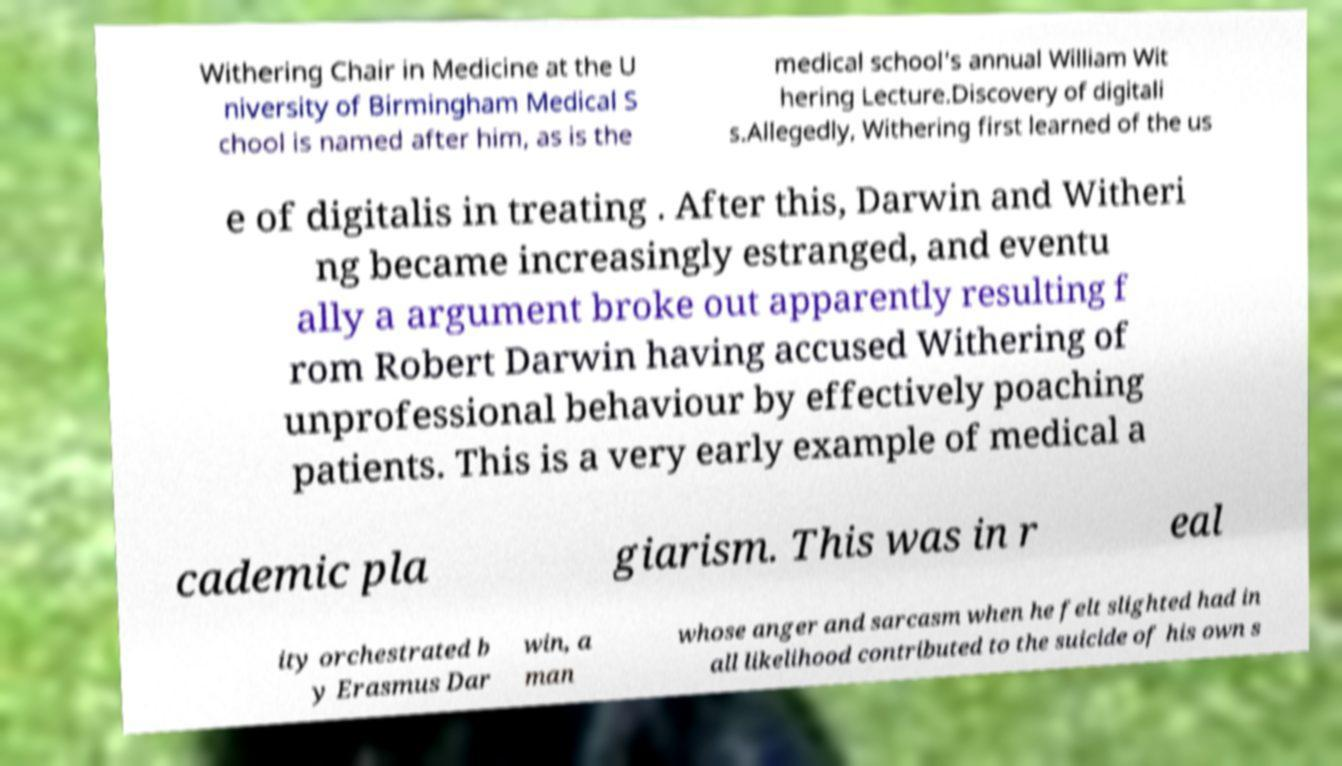Can you read and provide the text displayed in the image?This photo seems to have some interesting text. Can you extract and type it out for me? Withering Chair in Medicine at the U niversity of Birmingham Medical S chool is named after him, as is the medical school's annual William Wit hering Lecture.Discovery of digitali s.Allegedly, Withering first learned of the us e of digitalis in treating . After this, Darwin and Witheri ng became increasingly estranged, and eventu ally a argument broke out apparently resulting f rom Robert Darwin having accused Withering of unprofessional behaviour by effectively poaching patients. This is a very early example of medical a cademic pla giarism. This was in r eal ity orchestrated b y Erasmus Dar win, a man whose anger and sarcasm when he felt slighted had in all likelihood contributed to the suicide of his own s 